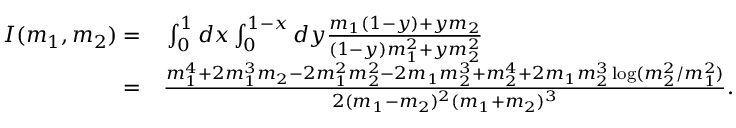<formula> <loc_0><loc_0><loc_500><loc_500>\begin{array} { r l } { I ( m _ { 1 } , m _ { 2 } ) = } & \int _ { 0 } ^ { 1 } d x \int _ { 0 } ^ { 1 - x } d y \frac { m _ { 1 } ( 1 - y ) + y m _ { 2 } } { ( 1 - y ) m _ { 1 } ^ { 2 } + y m _ { 2 } ^ { 2 } } } \\ { = } & \frac { m _ { 1 } ^ { 4 } + 2 m _ { 1 } ^ { 3 } m _ { 2 } - 2 m _ { 1 } ^ { 2 } m _ { 2 } ^ { 2 } - 2 m _ { 1 } m _ { 2 } ^ { 3 } + m _ { 2 } ^ { 4 } + 2 m _ { 1 } m _ { 2 } ^ { 3 } \log ( m _ { 2 } ^ { 2 } / m _ { 1 } ^ { 2 } ) } { 2 ( m _ { 1 } - m _ { 2 } ) ^ { 2 } ( m _ { 1 } + m _ { 2 } ) ^ { 3 } } . } \end{array}</formula> 